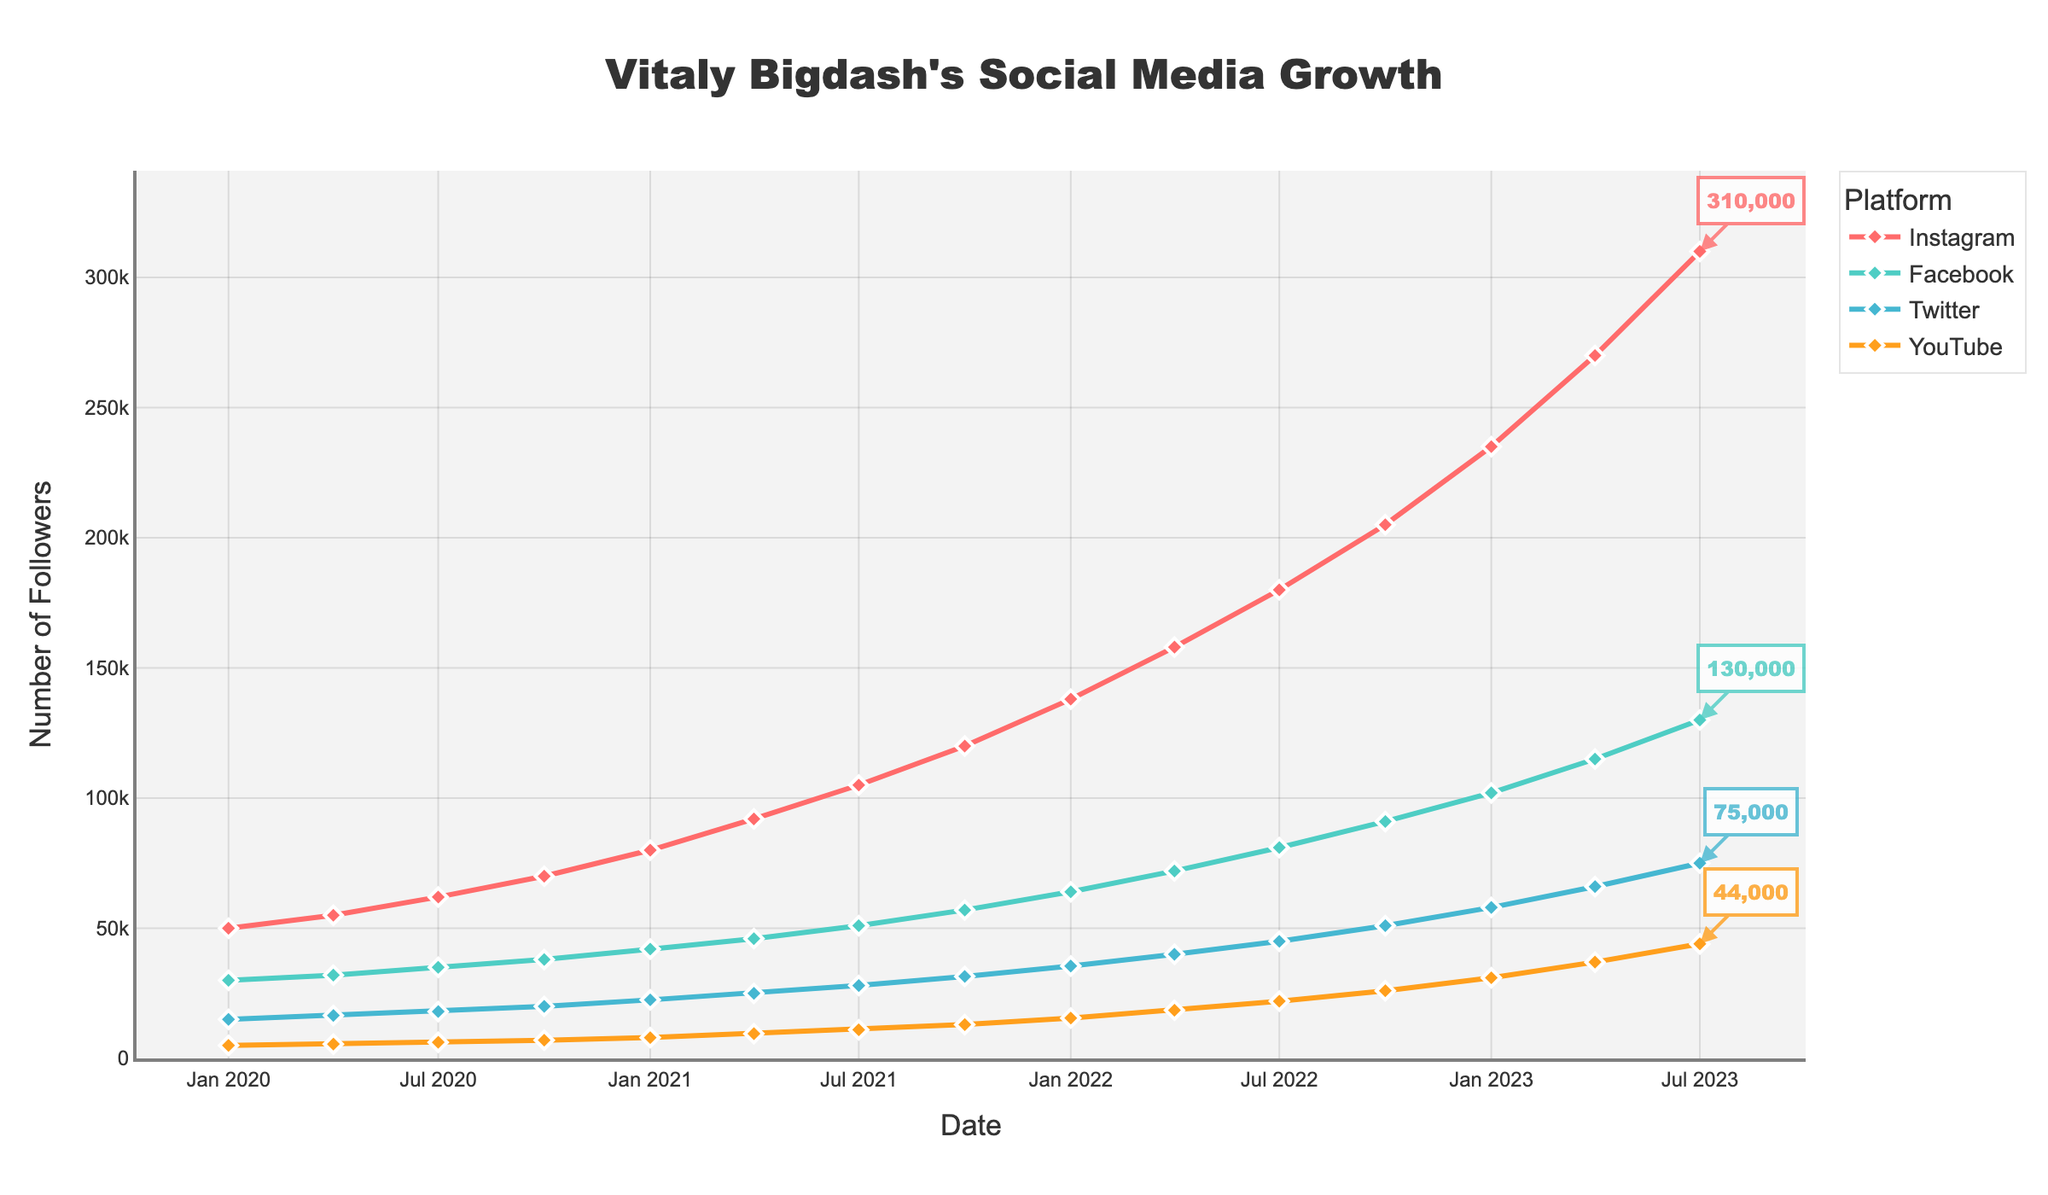Which platform had the highest number of followers as of July 2023? By looking at the line chart, identify the platform whose line is at the highest position on the vertical axis at the July 2023 data point.
Answer: Instagram Which platform saw the most significant growth between January 2020 and July 2023? Identify the difference between the follower counts in January 2020 and July 2023 for each platform, then compare to see which platform had the largest difference.
Answer: Instagram Around when did Facebook's followers count reach 57000? Locate the point on the Facebook line where the followers count reaches approximately 57000 and observe the corresponding date on the horizontal axis.
Answer: October 2021 Which platform had the smallest number of followers throughout 2020? Review the chart and find the platform whose line remains lowest during the period of January 2020 to December 2020.
Answer: YouTube Compare the follower growth of Twitter and YouTube from January 2021 to January 2022. Which had a steeper increase? Calculate the difference in followers for both Twitter and YouTube between January 2021 and January 2022, then compare the two values to identify which increase is greater. Twitter's growth: 35500 - 22500 = 13000. YouTube's growth: 15500 - 8000 = 7500.
Answer: Twitter During which period did Instagram's followers grow the most rapidly? Identify the segment(s) of the Instagram line with the steepest upward slope by comparing the increase in followers over each period. The steepest increase occurs between two specific points.
Answer: Between April 2023 and July 2023 How did YouTube's growth between July 2022 and October 2022 compare to its growth between October 2022 and January 2023? Calculate the growth in YouTube followers for both periods and compare these values. Growth from July to October 2022: 26000 - 22000 = 4000. Growth from October 2022 to January 2023: 31000 - 26000 = 5000.
Answer: The second period had greater growth What can you infer about the trend in growth for all platforms from 2020 to 2023? Examine the overall slope and pattern of each line over the entire period and describe general trends in terms of increase or stabilization of follower counts.
Answer: Steady increase Which two platforms had the closest number of followers in January 2021? Look at the follower counts of each platform in January 2021 and determine which two platforms' numbers are most similar. Facebook: 42000, Twitter: 22500, YouTube: 8000, Instagram: 80000. Twitter and YouTube have the closest counts.
Answer: Twitter and YouTube 